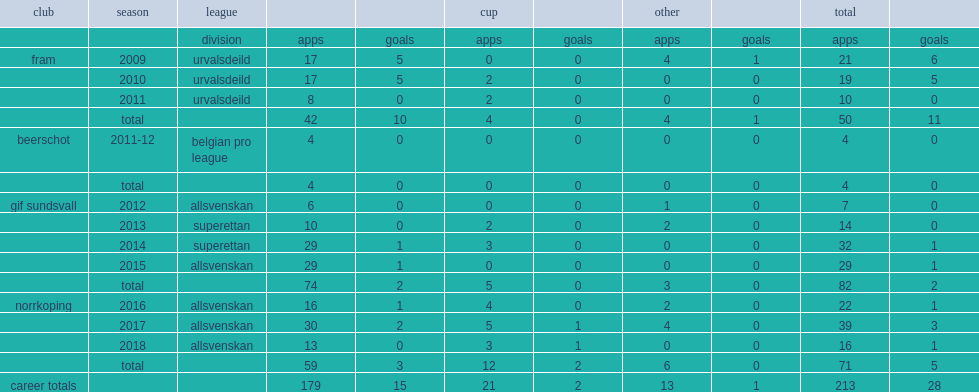In 2012, which league jon guðni fjoluson joined with gif sundsvall in allsvenskan. Allsvenskan. 